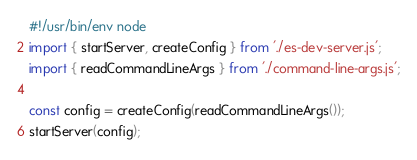<code> <loc_0><loc_0><loc_500><loc_500><_JavaScript_>#!/usr/bin/env node
import { startServer, createConfig } from './es-dev-server.js';
import { readCommandLineArgs } from './command-line-args.js';

const config = createConfig(readCommandLineArgs());
startServer(config);
</code> 